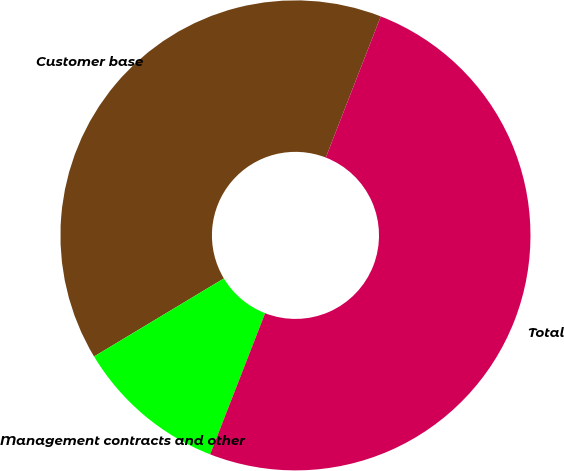Convert chart to OTSL. <chart><loc_0><loc_0><loc_500><loc_500><pie_chart><fcel>Customer base<fcel>Management contracts and other<fcel>Total<nl><fcel>39.53%<fcel>10.47%<fcel>50.0%<nl></chart> 